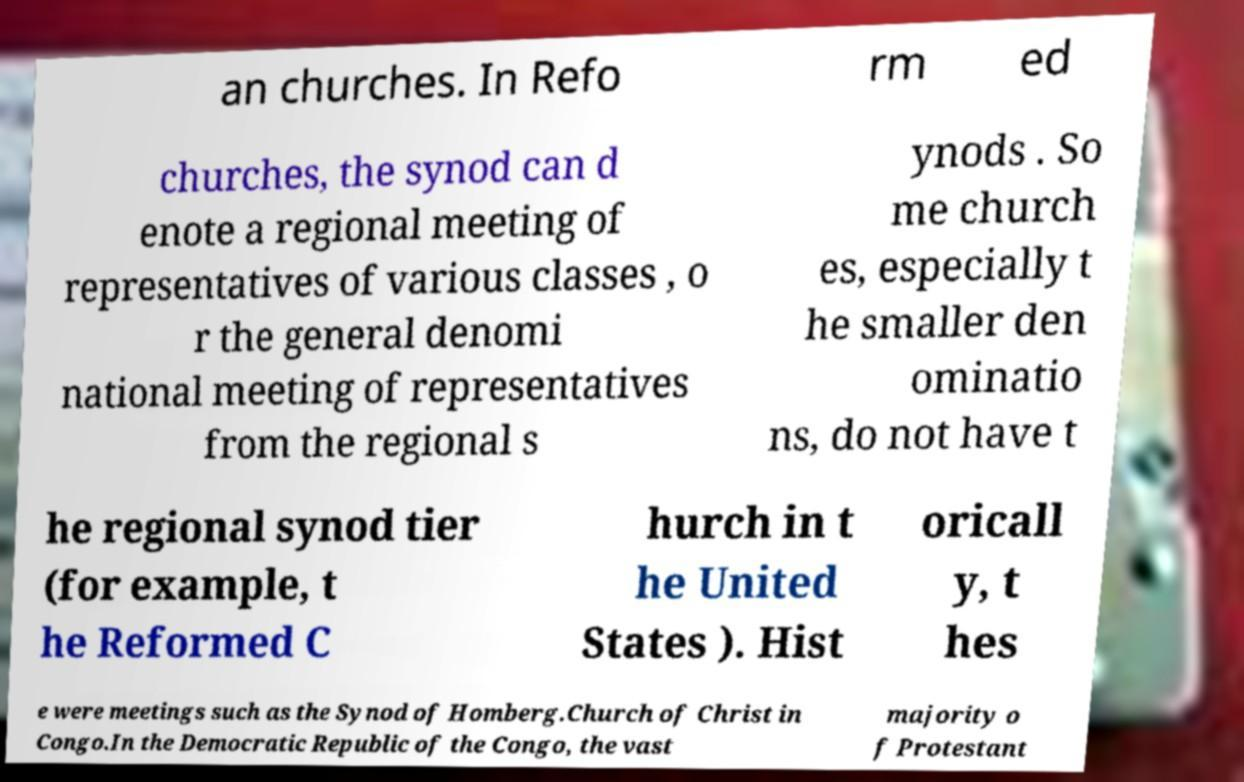I need the written content from this picture converted into text. Can you do that? an churches. In Refo rm ed churches, the synod can d enote a regional meeting of representatives of various classes , o r the general denomi national meeting of representatives from the regional s ynods . So me church es, especially t he smaller den ominatio ns, do not have t he regional synod tier (for example, t he Reformed C hurch in t he United States ). Hist oricall y, t hes e were meetings such as the Synod of Homberg.Church of Christ in Congo.In the Democratic Republic of the Congo, the vast majority o f Protestant 